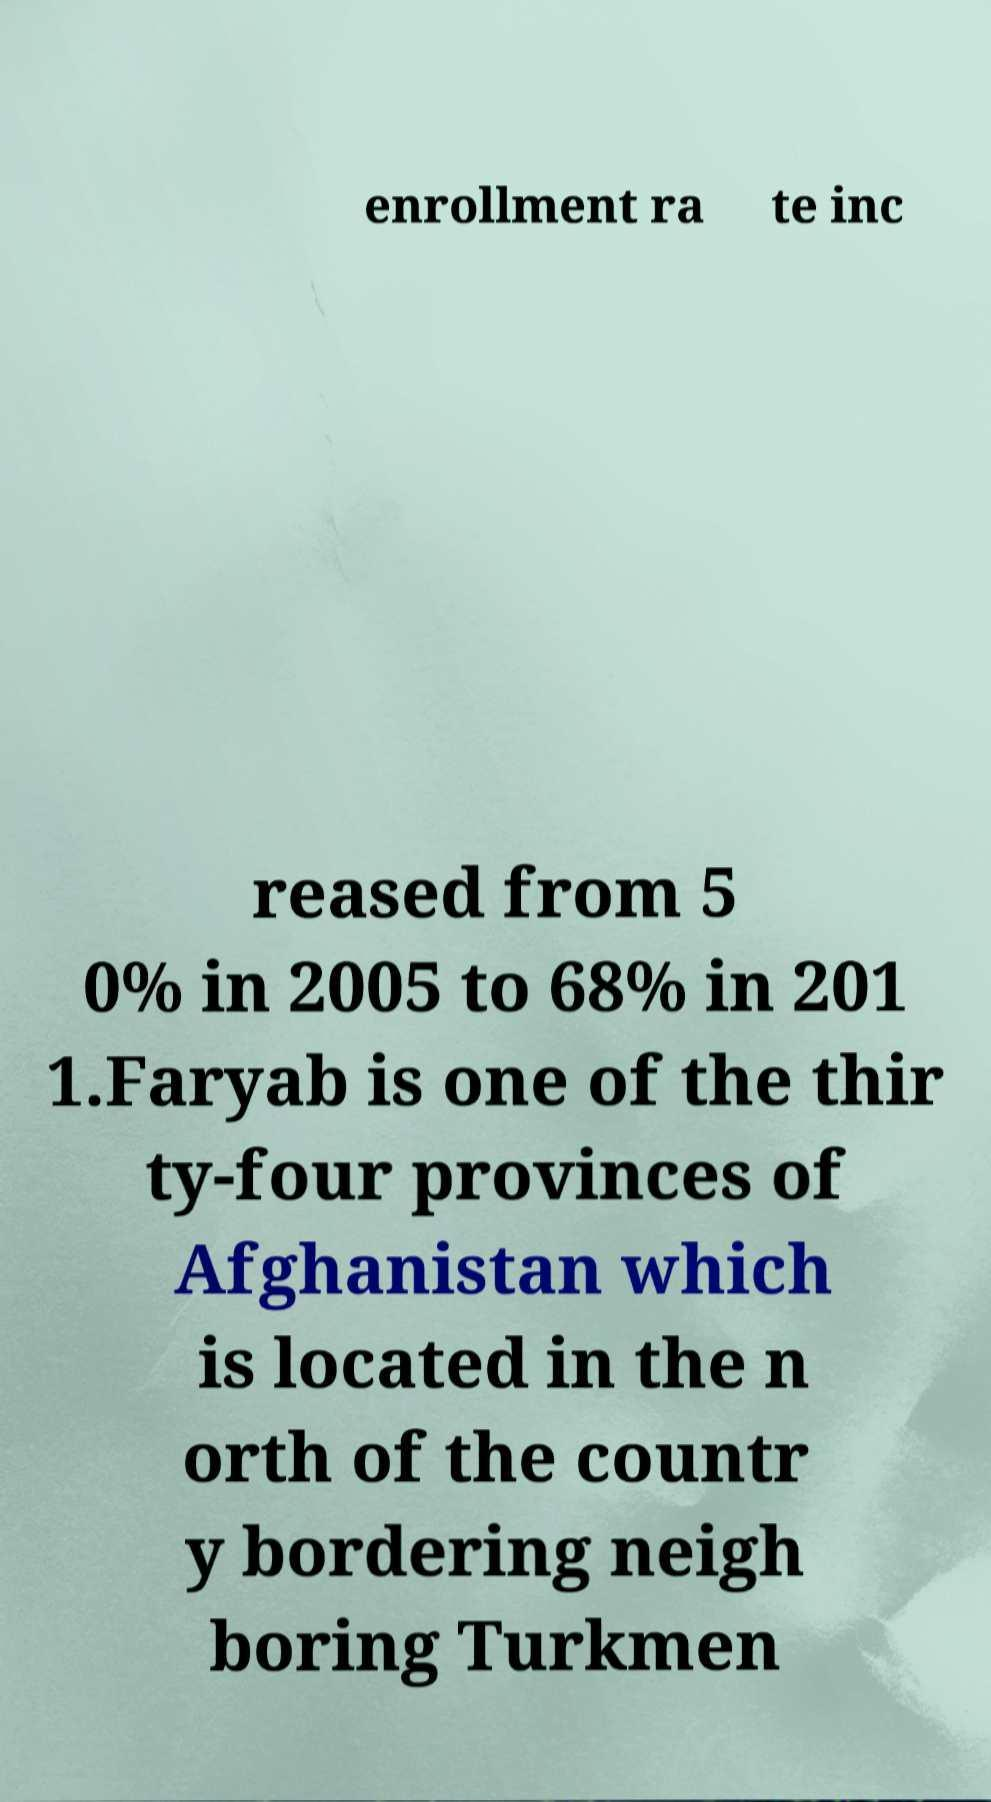I need the written content from this picture converted into text. Can you do that? enrollment ra te inc reased from 5 0% in 2005 to 68% in 201 1.Faryab is one of the thir ty-four provinces of Afghanistan which is located in the n orth of the countr y bordering neigh boring Turkmen 